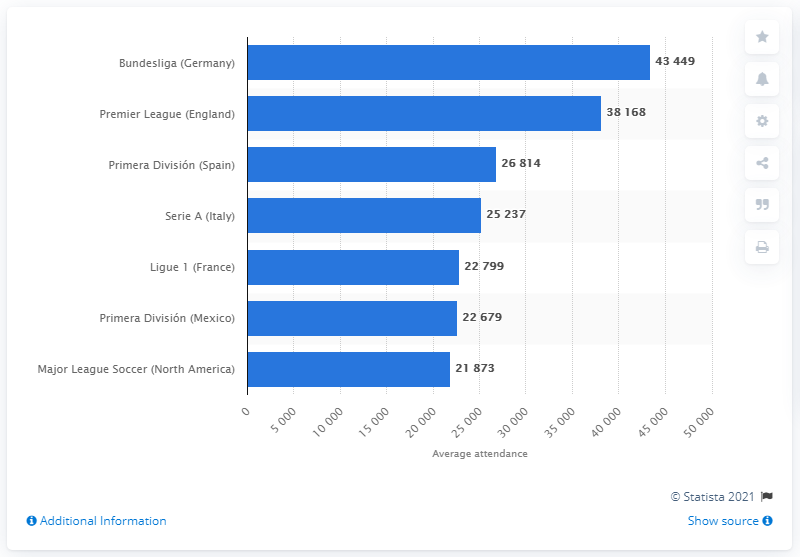Draw attention to some important aspects in this diagram. The attendance for the Premier League (England) is 38,168. The attendance for Major League Soccer is currently 21,873. 